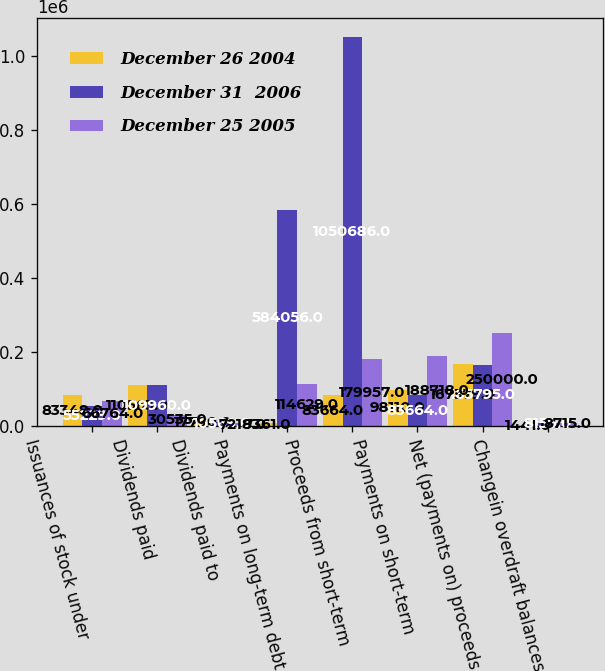Convert chart to OTSL. <chart><loc_0><loc_0><loc_500><loc_500><stacked_bar_chart><ecel><fcel>Issuances of stock under<fcel>Dividends paid<fcel>Dividends paid to<fcel>Payments on long-term debt<fcel>Proceeds from short-term<fcel>Payments on short-term<fcel>Net (payments on) proceeds<fcel>Changein overdraft balances<nl><fcel>December 26 2004<fcel>83348<fcel>110563<fcel>17790<fcel>7361<fcel>83664<fcel>98110<fcel>167379<fcel>1441<nl><fcel>December 31  2006<fcel>55229<fcel>109960<fcel>10569<fcel>584056<fcel>1.05069e+06<fcel>83664<fcel>165795<fcel>8159<nl><fcel>December 25 2005<fcel>66764<fcel>30535<fcel>7218<fcel>114629<fcel>179957<fcel>188718<fcel>250000<fcel>8715<nl></chart> 